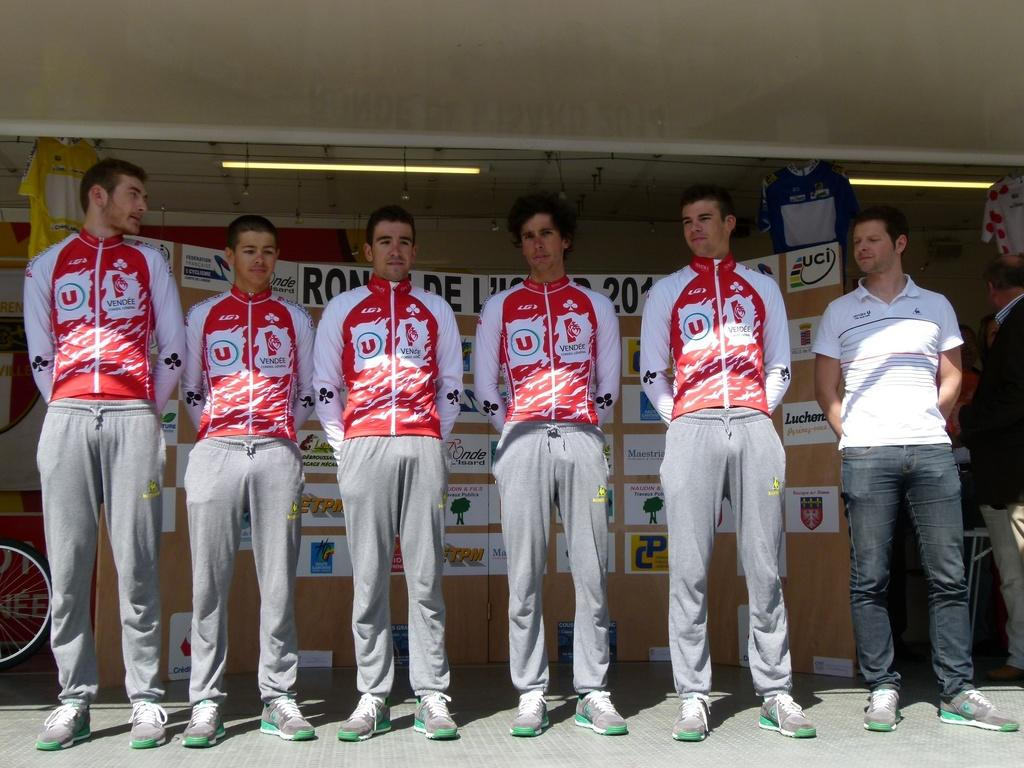<image>
Give a short and clear explanation of the subsequent image. Five young men stand on a stage in matching Vendee jackets. 